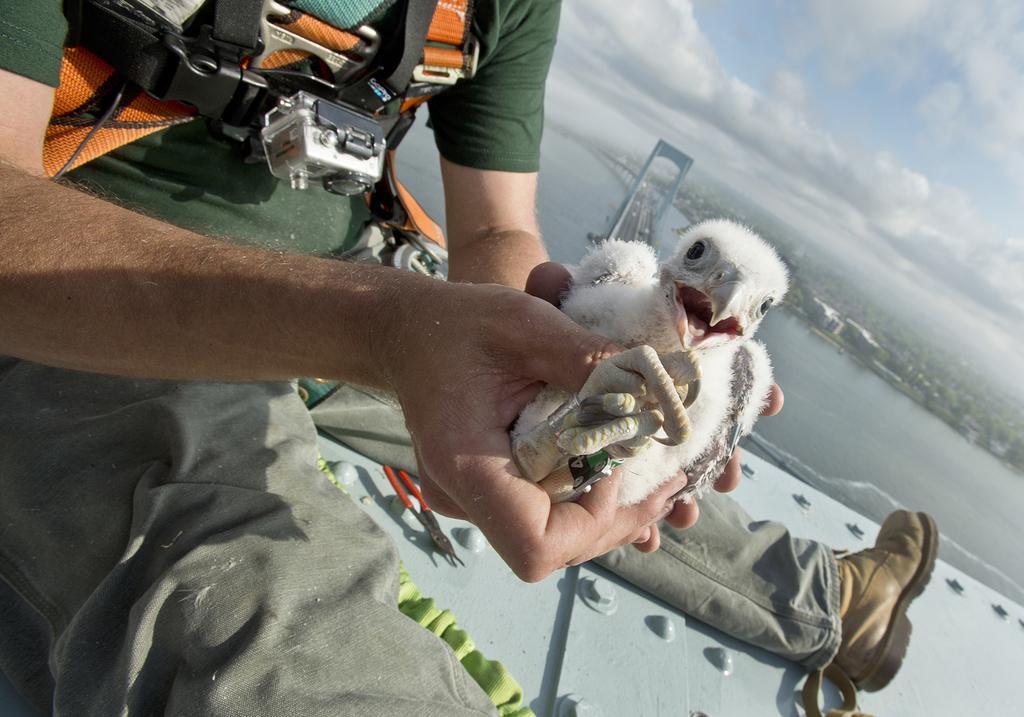Please provide a concise description of this image. In this picture, we see a man in the green T-shirt is sitting and he is holding a bird in his hands. He is wearing a black and orange color belt. In front of him, we see a cutting plier and a cloth in green color. In the middle, we see a bridge and the water. This water might be in the river. On the right side, we see the buildings and trees. In the right top, we see the sky and the clouds. 